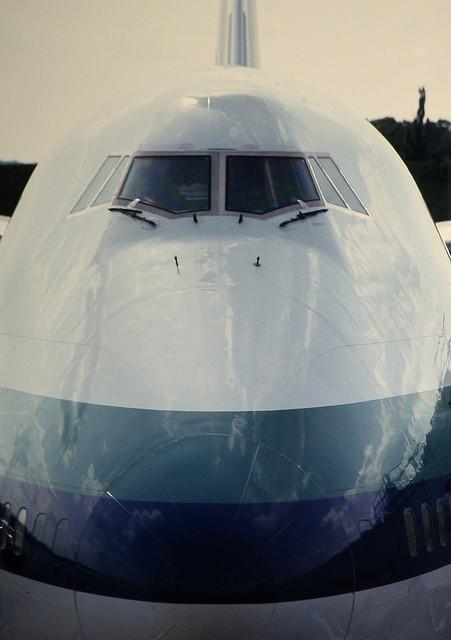How many windows are visible?
Give a very brief answer. 6. 